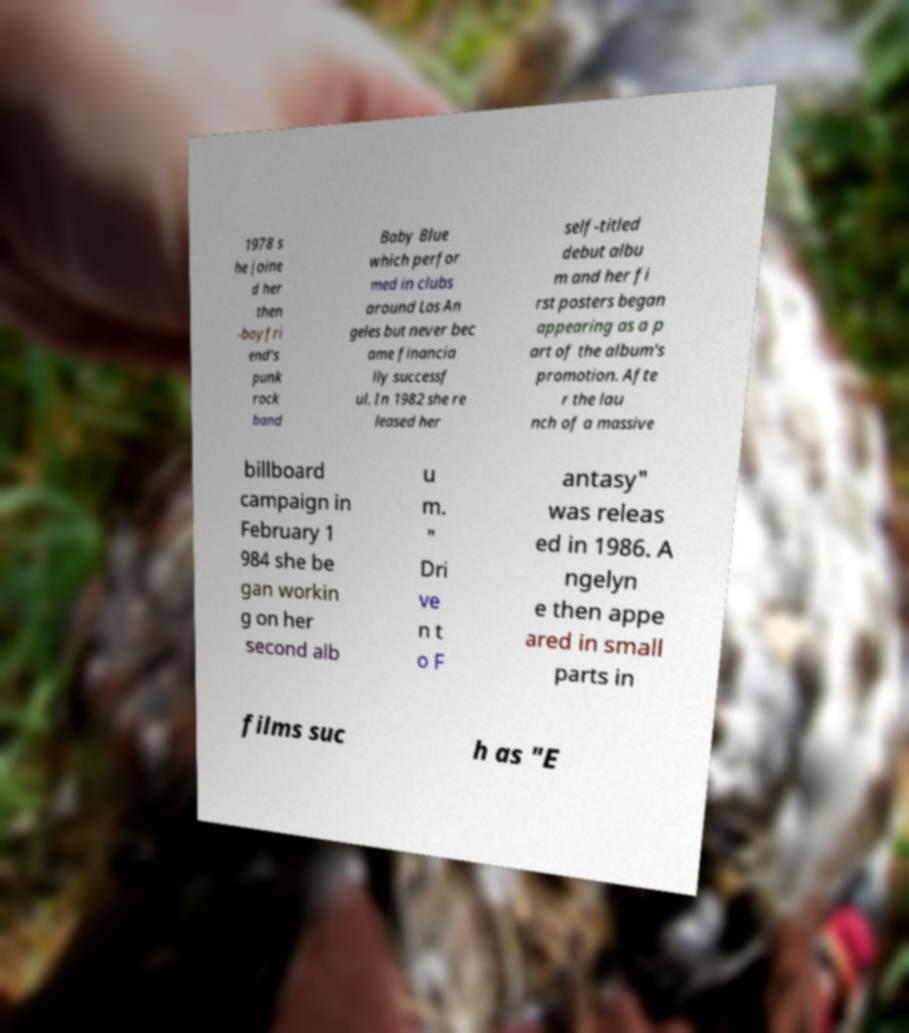Can you read and provide the text displayed in the image?This photo seems to have some interesting text. Can you extract and type it out for me? 1978 s he joine d her then -boyfri end's punk rock band Baby Blue which perfor med in clubs around Los An geles but never bec ame financia lly successf ul. In 1982 she re leased her self-titled debut albu m and her fi rst posters began appearing as a p art of the album's promotion. Afte r the lau nch of a massive billboard campaign in February 1 984 she be gan workin g on her second alb u m. " Dri ve n t o F antasy" was releas ed in 1986. A ngelyn e then appe ared in small parts in films suc h as "E 